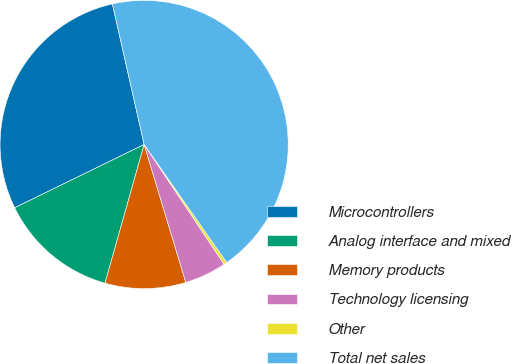Convert chart to OTSL. <chart><loc_0><loc_0><loc_500><loc_500><pie_chart><fcel>Microcontrollers<fcel>Analog interface and mixed<fcel>Memory products<fcel>Technology licensing<fcel>Other<fcel>Total net sales<nl><fcel>28.7%<fcel>13.39%<fcel>9.04%<fcel>4.7%<fcel>0.35%<fcel>43.82%<nl></chart> 